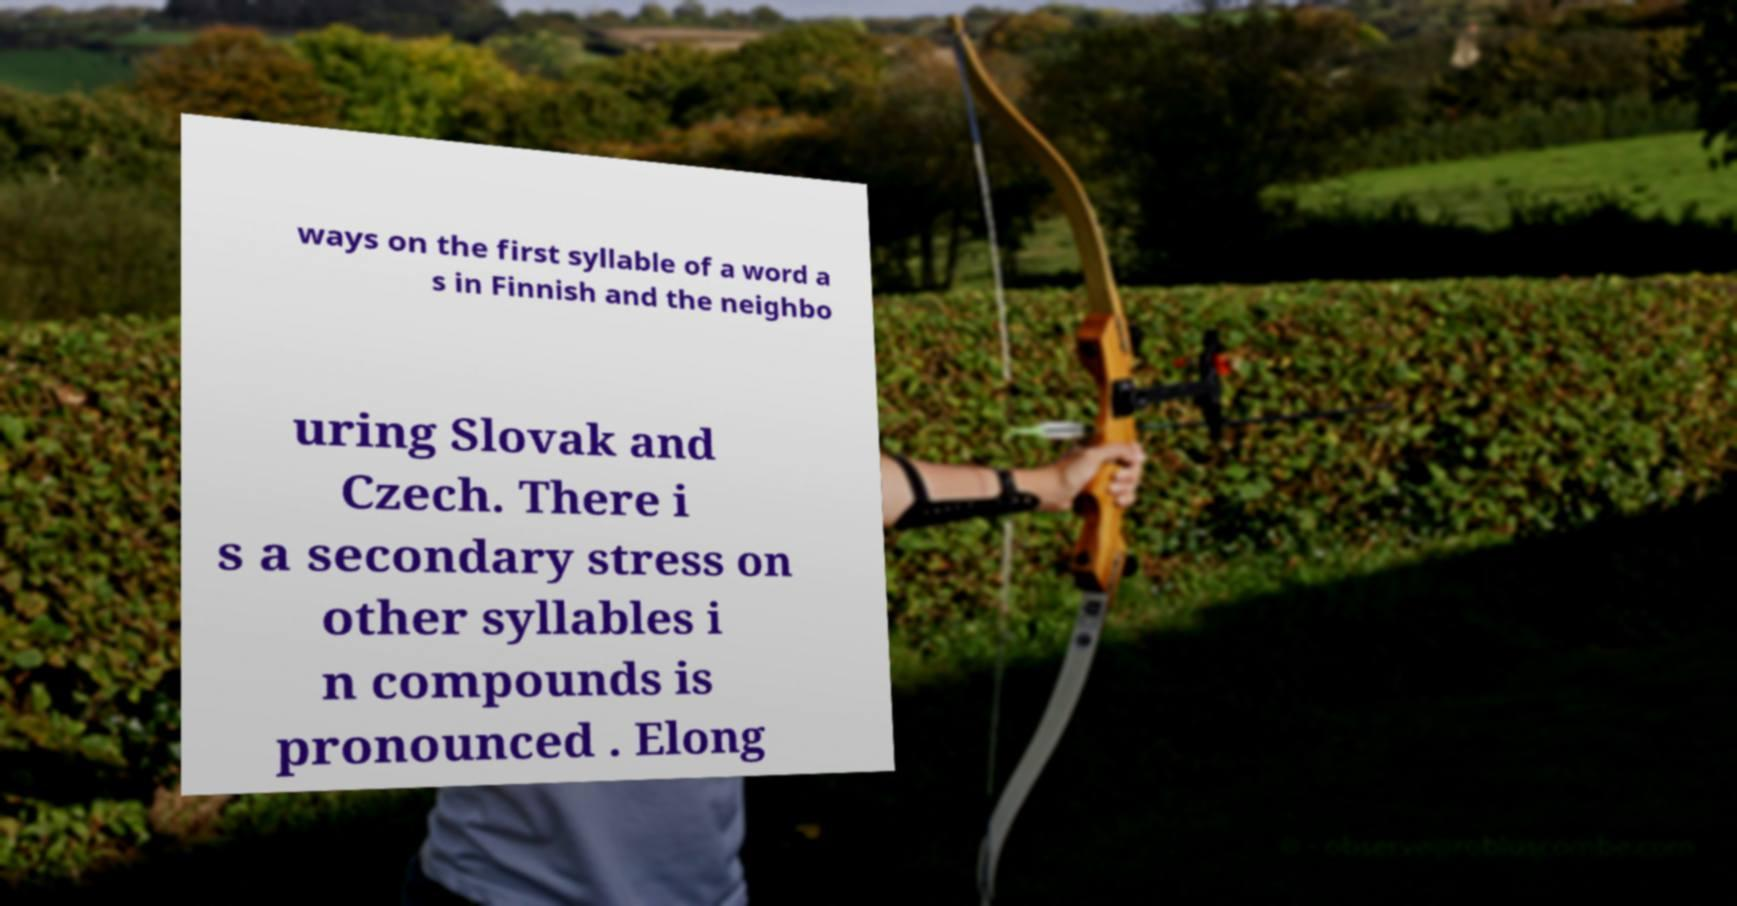Can you accurately transcribe the text from the provided image for me? ways on the first syllable of a word a s in Finnish and the neighbo uring Slovak and Czech. There i s a secondary stress on other syllables i n compounds is pronounced . Elong 